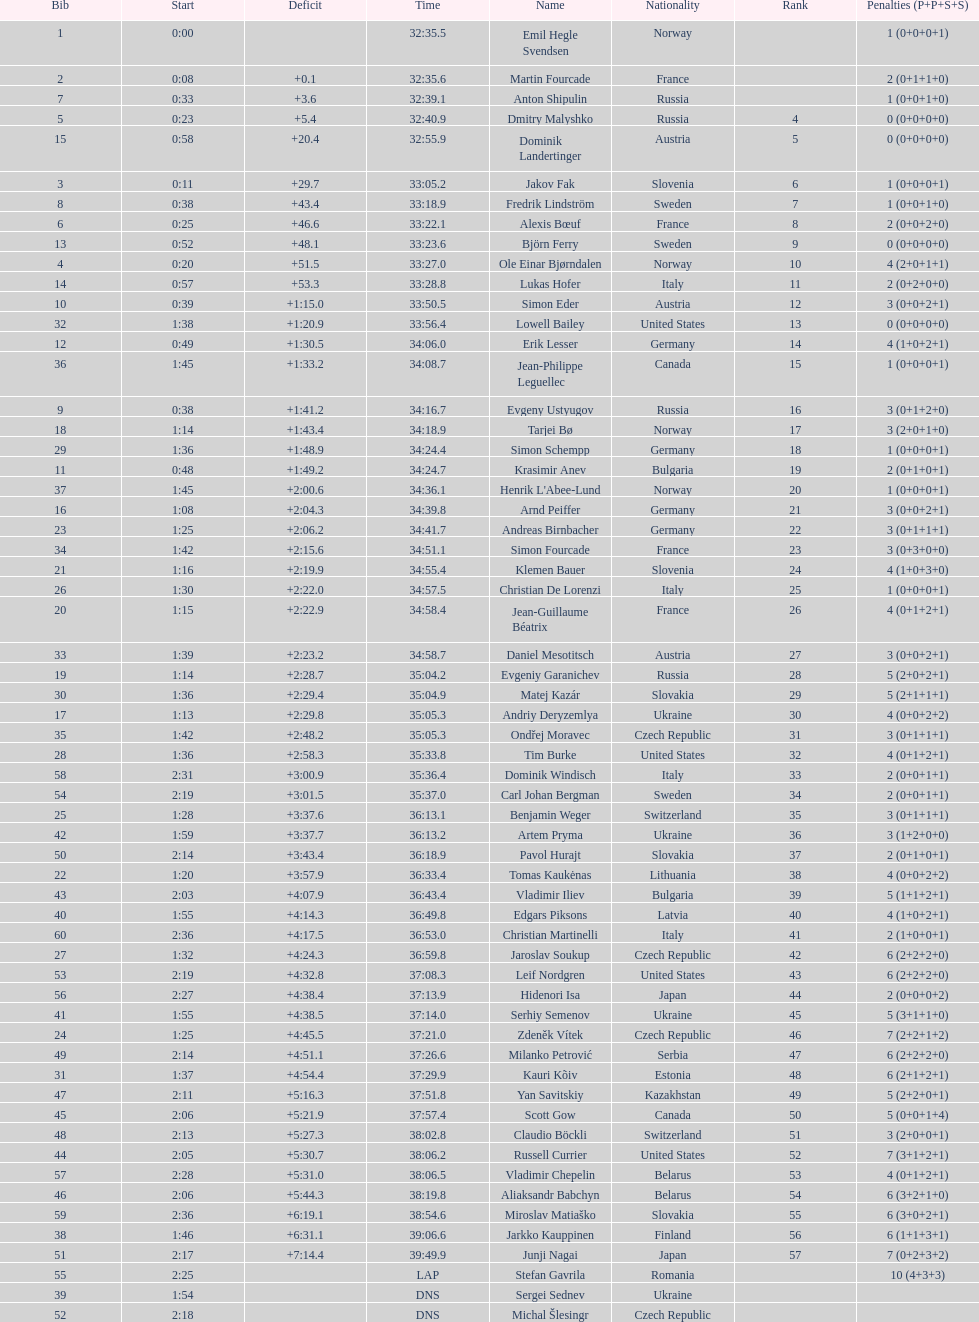What is the number of russian participants? 4. 